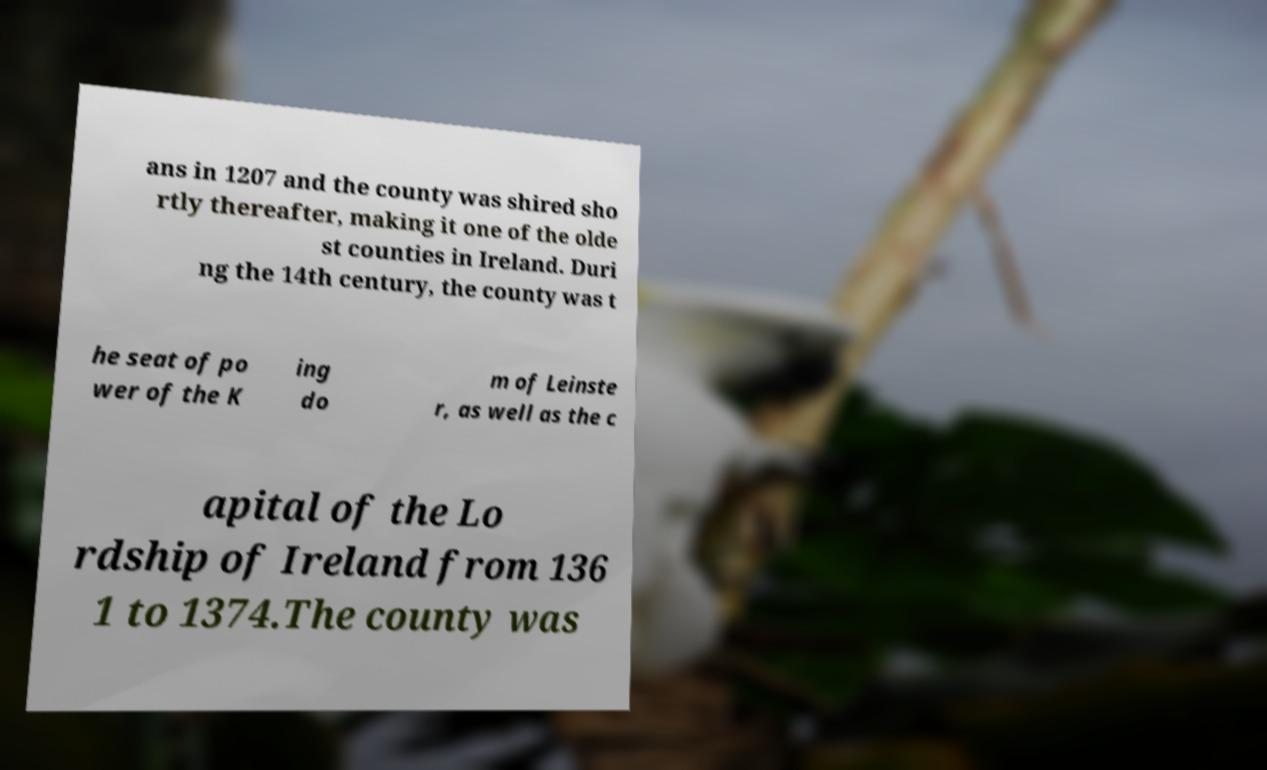Can you read and provide the text displayed in the image?This photo seems to have some interesting text. Can you extract and type it out for me? ans in 1207 and the county was shired sho rtly thereafter, making it one of the olde st counties in Ireland. Duri ng the 14th century, the county was t he seat of po wer of the K ing do m of Leinste r, as well as the c apital of the Lo rdship of Ireland from 136 1 to 1374.The county was 